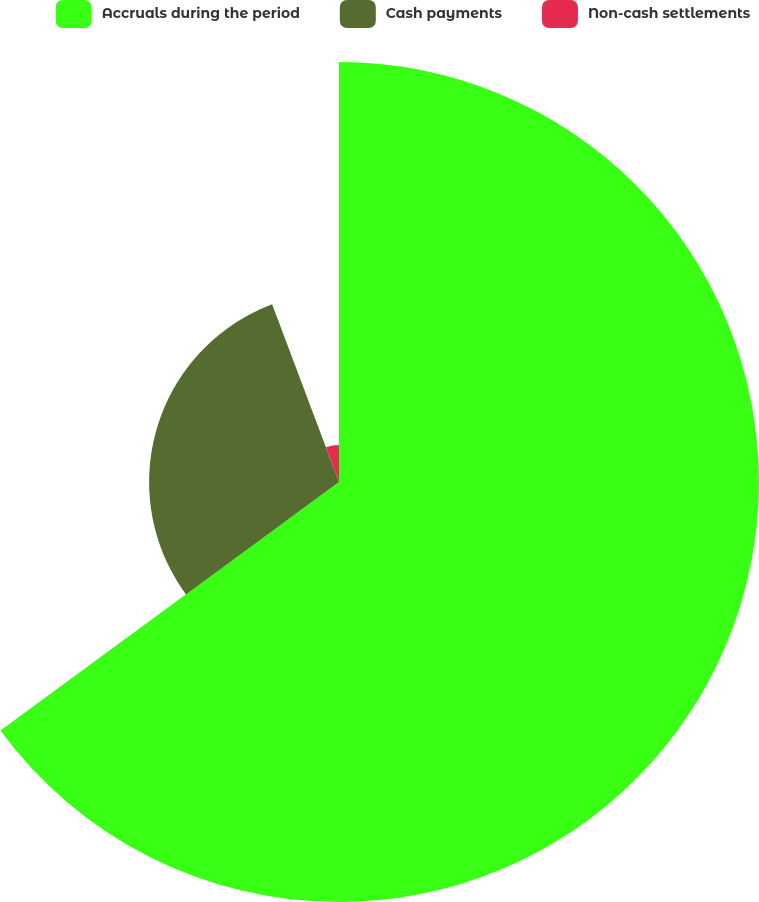Convert chart to OTSL. <chart><loc_0><loc_0><loc_500><loc_500><pie_chart><fcel>Accruals during the period<fcel>Cash payments<fcel>Non-cash settlements<nl><fcel>64.92%<fcel>29.35%<fcel>5.73%<nl></chart> 